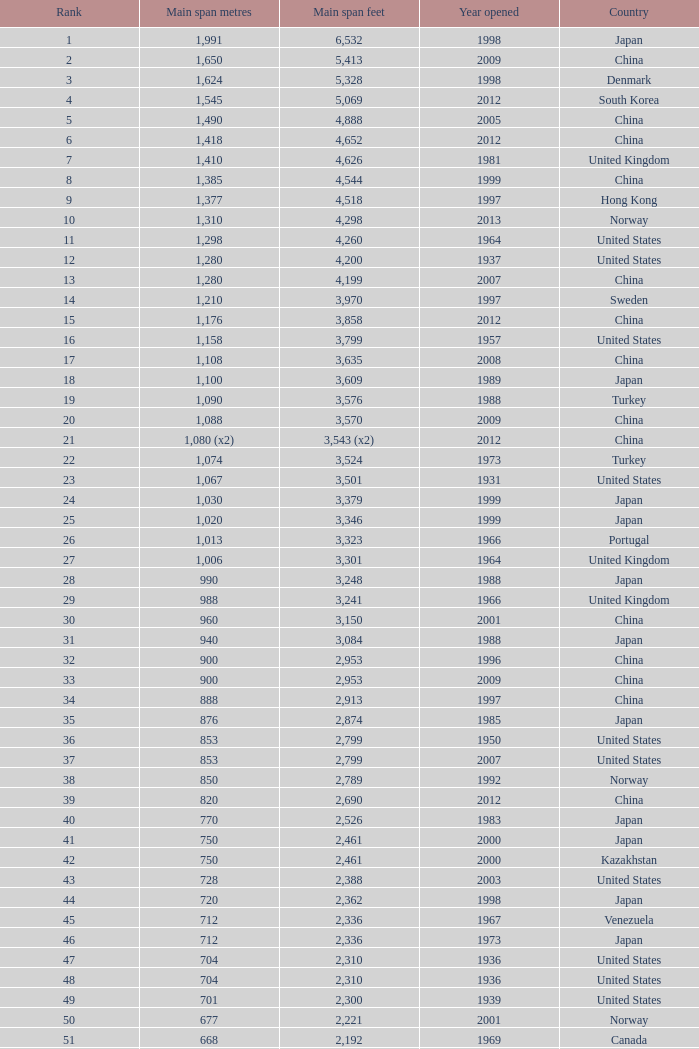What is the utmost rank from the year surpassing 2010 with 430 chief span metres? 94.0. 